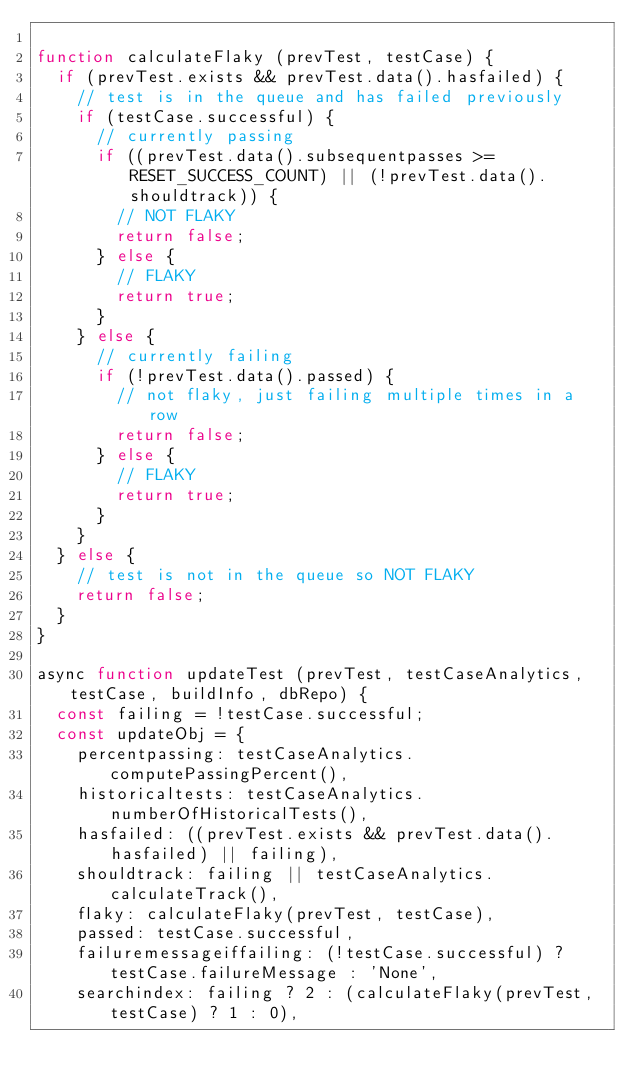Convert code to text. <code><loc_0><loc_0><loc_500><loc_500><_JavaScript_>
function calculateFlaky (prevTest, testCase) {
  if (prevTest.exists && prevTest.data().hasfailed) {
    // test is in the queue and has failed previously
    if (testCase.successful) {
      // currently passing
      if ((prevTest.data().subsequentpasses >= RESET_SUCCESS_COUNT) || (!prevTest.data().shouldtrack)) {
        // NOT FLAKY
        return false;
      } else {
        // FLAKY
        return true;
      }
    } else {
      // currently failing
      if (!prevTest.data().passed) {
        // not flaky, just failing multiple times in a row
        return false;
      } else {
        // FLAKY
        return true;
      }
    }
  } else {
    // test is not in the queue so NOT FLAKY
    return false;
  }
}

async function updateTest (prevTest, testCaseAnalytics, testCase, buildInfo, dbRepo) {
  const failing = !testCase.successful;
  const updateObj = {
    percentpassing: testCaseAnalytics.computePassingPercent(),
    historicaltests: testCaseAnalytics.numberOfHistoricalTests(),
    hasfailed: ((prevTest.exists && prevTest.data().hasfailed) || failing),
    shouldtrack: failing || testCaseAnalytics.calculateTrack(),
    flaky: calculateFlaky(prevTest, testCase),
    passed: testCase.successful,
    failuremessageiffailing: (!testCase.successful) ? testCase.failureMessage : 'None',
    searchindex: failing ? 2 : (calculateFlaky(prevTest, testCase) ? 1 : 0),</code> 